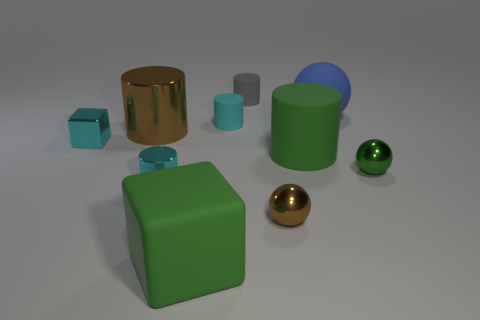Are there any cyan shiny things that have the same size as the blue matte object?
Your answer should be compact. No. Are the block that is in front of the tiny green sphere and the large brown object made of the same material?
Keep it short and to the point. No. Are there an equal number of matte cylinders in front of the small brown metallic sphere and tiny rubber cylinders on the left side of the large brown thing?
Provide a short and direct response. Yes. There is a metallic thing that is both behind the tiny brown thing and to the right of the matte cube; what shape is it?
Your answer should be very brief. Sphere. There is a cyan shiny cylinder; how many big blue matte spheres are in front of it?
Offer a very short reply. 0. What number of other things are there of the same shape as the blue matte thing?
Offer a terse response. 2. Are there fewer large metallic cylinders than small blue shiny balls?
Provide a short and direct response. No. What is the size of the thing that is right of the green cylinder and behind the small green metal object?
Your response must be concise. Large. What is the size of the matte object in front of the green object that is to the right of the matte cylinder that is to the right of the gray cylinder?
Provide a short and direct response. Large. The shiny block is what size?
Offer a terse response. Small. 